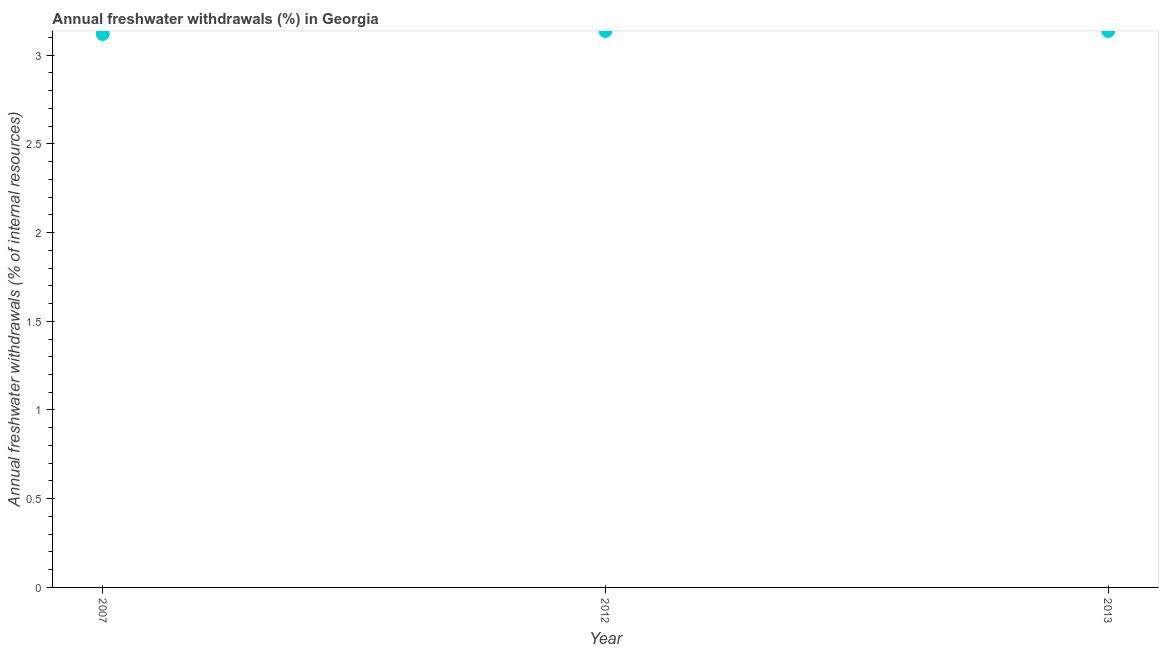What is the annual freshwater withdrawals in 2007?
Your answer should be very brief. 3.12. Across all years, what is the maximum annual freshwater withdrawals?
Make the answer very short. 3.14. Across all years, what is the minimum annual freshwater withdrawals?
Give a very brief answer. 3.12. What is the sum of the annual freshwater withdrawals?
Offer a very short reply. 9.39. What is the difference between the annual freshwater withdrawals in 2007 and 2013?
Give a very brief answer. -0.02. What is the average annual freshwater withdrawals per year?
Provide a succinct answer. 3.13. What is the median annual freshwater withdrawals?
Provide a succinct answer. 3.14. Do a majority of the years between 2013 and 2012 (inclusive) have annual freshwater withdrawals greater than 1.1 %?
Your response must be concise. No. What is the ratio of the annual freshwater withdrawals in 2007 to that in 2012?
Ensure brevity in your answer.  0.99. Is the sum of the annual freshwater withdrawals in 2007 and 2013 greater than the maximum annual freshwater withdrawals across all years?
Offer a terse response. Yes. What is the difference between the highest and the lowest annual freshwater withdrawals?
Provide a short and direct response. 0.02. How many years are there in the graph?
Your answer should be very brief. 3. Does the graph contain grids?
Give a very brief answer. No. What is the title of the graph?
Keep it short and to the point. Annual freshwater withdrawals (%) in Georgia. What is the label or title of the Y-axis?
Provide a succinct answer. Annual freshwater withdrawals (% of internal resources). What is the Annual freshwater withdrawals (% of internal resources) in 2007?
Offer a very short reply. 3.12. What is the Annual freshwater withdrawals (% of internal resources) in 2012?
Ensure brevity in your answer.  3.14. What is the Annual freshwater withdrawals (% of internal resources) in 2013?
Keep it short and to the point. 3.14. What is the difference between the Annual freshwater withdrawals (% of internal resources) in 2007 and 2012?
Keep it short and to the point. -0.02. What is the difference between the Annual freshwater withdrawals (% of internal resources) in 2007 and 2013?
Keep it short and to the point. -0.02. What is the difference between the Annual freshwater withdrawals (% of internal resources) in 2012 and 2013?
Offer a terse response. 0. 